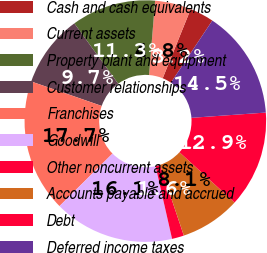Convert chart to OTSL. <chart><loc_0><loc_0><loc_500><loc_500><pie_chart><fcel>Cash and cash equivalents<fcel>Current assets<fcel>Property plant and equipment<fcel>Customer relationships<fcel>Franchises<fcel>Goodwill<fcel>Other noncurrent assets<fcel>Accounts payable and accrued<fcel>Debt<fcel>Deferred income taxes<nl><fcel>3.23%<fcel>4.84%<fcel>11.29%<fcel>9.68%<fcel>17.74%<fcel>16.13%<fcel>1.61%<fcel>8.06%<fcel>12.9%<fcel>14.52%<nl></chart> 